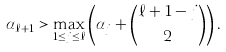Convert formula to latex. <formula><loc_0><loc_0><loc_500><loc_500>\alpha _ { \ell + 1 } > \max _ { 1 \leq j \leq \ell } \left ( \alpha _ { j } + \binom { \ell + 1 - j } { 2 } \right ) .</formula> 